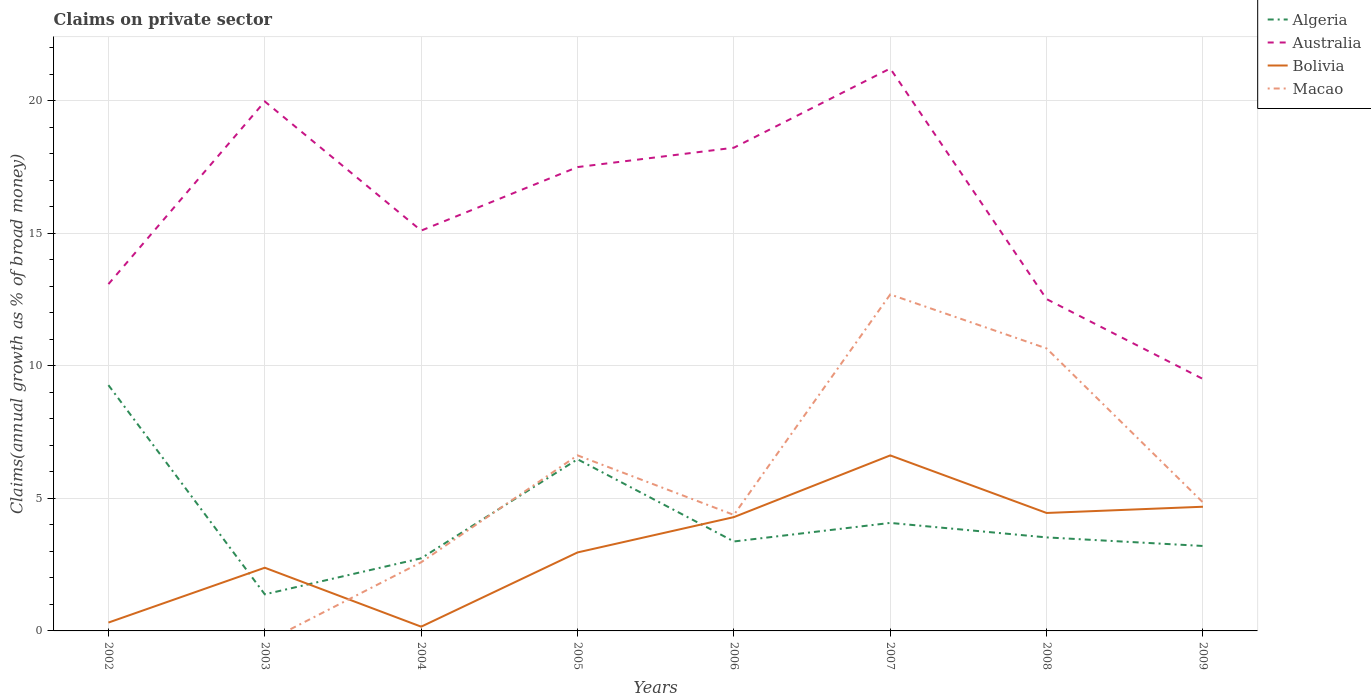How many different coloured lines are there?
Offer a terse response. 4. Is the number of lines equal to the number of legend labels?
Provide a short and direct response. No. Across all years, what is the maximum percentage of broad money claimed on private sector in Algeria?
Make the answer very short. 1.38. What is the total percentage of broad money claimed on private sector in Australia in the graph?
Make the answer very short. 8.73. What is the difference between the highest and the second highest percentage of broad money claimed on private sector in Macao?
Make the answer very short. 12.7. What is the difference between two consecutive major ticks on the Y-axis?
Offer a terse response. 5. Are the values on the major ticks of Y-axis written in scientific E-notation?
Ensure brevity in your answer.  No. Does the graph contain any zero values?
Your answer should be very brief. Yes. Where does the legend appear in the graph?
Your answer should be compact. Top right. How many legend labels are there?
Provide a short and direct response. 4. How are the legend labels stacked?
Make the answer very short. Vertical. What is the title of the graph?
Provide a short and direct response. Claims on private sector. What is the label or title of the X-axis?
Keep it short and to the point. Years. What is the label or title of the Y-axis?
Your answer should be very brief. Claims(annual growth as % of broad money). What is the Claims(annual growth as % of broad money) of Algeria in 2002?
Keep it short and to the point. 9.27. What is the Claims(annual growth as % of broad money) in Australia in 2002?
Your response must be concise. 13.09. What is the Claims(annual growth as % of broad money) in Bolivia in 2002?
Provide a succinct answer. 0.31. What is the Claims(annual growth as % of broad money) in Macao in 2002?
Provide a succinct answer. 0. What is the Claims(annual growth as % of broad money) of Algeria in 2003?
Offer a terse response. 1.38. What is the Claims(annual growth as % of broad money) of Australia in 2003?
Give a very brief answer. 19.98. What is the Claims(annual growth as % of broad money) of Bolivia in 2003?
Ensure brevity in your answer.  2.38. What is the Claims(annual growth as % of broad money) of Algeria in 2004?
Offer a terse response. 2.74. What is the Claims(annual growth as % of broad money) of Australia in 2004?
Provide a short and direct response. 15.11. What is the Claims(annual growth as % of broad money) of Bolivia in 2004?
Your answer should be compact. 0.16. What is the Claims(annual growth as % of broad money) in Macao in 2004?
Provide a succinct answer. 2.59. What is the Claims(annual growth as % of broad money) in Algeria in 2005?
Ensure brevity in your answer.  6.48. What is the Claims(annual growth as % of broad money) of Australia in 2005?
Provide a short and direct response. 17.5. What is the Claims(annual growth as % of broad money) of Bolivia in 2005?
Provide a succinct answer. 2.96. What is the Claims(annual growth as % of broad money) in Macao in 2005?
Give a very brief answer. 6.63. What is the Claims(annual growth as % of broad money) of Algeria in 2006?
Offer a terse response. 3.38. What is the Claims(annual growth as % of broad money) in Australia in 2006?
Your response must be concise. 18.23. What is the Claims(annual growth as % of broad money) in Bolivia in 2006?
Provide a short and direct response. 4.29. What is the Claims(annual growth as % of broad money) in Macao in 2006?
Your answer should be very brief. 4.38. What is the Claims(annual growth as % of broad money) of Algeria in 2007?
Offer a terse response. 4.08. What is the Claims(annual growth as % of broad money) of Australia in 2007?
Keep it short and to the point. 21.22. What is the Claims(annual growth as % of broad money) of Bolivia in 2007?
Provide a succinct answer. 6.62. What is the Claims(annual growth as % of broad money) in Macao in 2007?
Ensure brevity in your answer.  12.7. What is the Claims(annual growth as % of broad money) in Algeria in 2008?
Provide a short and direct response. 3.53. What is the Claims(annual growth as % of broad money) in Australia in 2008?
Keep it short and to the point. 12.52. What is the Claims(annual growth as % of broad money) of Bolivia in 2008?
Offer a very short reply. 4.45. What is the Claims(annual growth as % of broad money) of Macao in 2008?
Ensure brevity in your answer.  10.66. What is the Claims(annual growth as % of broad money) in Algeria in 2009?
Your answer should be very brief. 3.21. What is the Claims(annual growth as % of broad money) in Australia in 2009?
Give a very brief answer. 9.51. What is the Claims(annual growth as % of broad money) of Bolivia in 2009?
Your answer should be compact. 4.69. What is the Claims(annual growth as % of broad money) of Macao in 2009?
Offer a terse response. 4.85. Across all years, what is the maximum Claims(annual growth as % of broad money) of Algeria?
Give a very brief answer. 9.27. Across all years, what is the maximum Claims(annual growth as % of broad money) in Australia?
Offer a terse response. 21.22. Across all years, what is the maximum Claims(annual growth as % of broad money) of Bolivia?
Give a very brief answer. 6.62. Across all years, what is the maximum Claims(annual growth as % of broad money) in Macao?
Your answer should be very brief. 12.7. Across all years, what is the minimum Claims(annual growth as % of broad money) in Algeria?
Your answer should be very brief. 1.38. Across all years, what is the minimum Claims(annual growth as % of broad money) of Australia?
Keep it short and to the point. 9.51. Across all years, what is the minimum Claims(annual growth as % of broad money) in Bolivia?
Give a very brief answer. 0.16. What is the total Claims(annual growth as % of broad money) in Algeria in the graph?
Ensure brevity in your answer.  34.06. What is the total Claims(annual growth as % of broad money) in Australia in the graph?
Ensure brevity in your answer.  127.16. What is the total Claims(annual growth as % of broad money) in Bolivia in the graph?
Make the answer very short. 25.88. What is the total Claims(annual growth as % of broad money) in Macao in the graph?
Provide a succinct answer. 41.8. What is the difference between the Claims(annual growth as % of broad money) in Algeria in 2002 and that in 2003?
Give a very brief answer. 7.89. What is the difference between the Claims(annual growth as % of broad money) in Australia in 2002 and that in 2003?
Ensure brevity in your answer.  -6.89. What is the difference between the Claims(annual growth as % of broad money) of Bolivia in 2002 and that in 2003?
Your answer should be compact. -2.07. What is the difference between the Claims(annual growth as % of broad money) in Algeria in 2002 and that in 2004?
Give a very brief answer. 6.53. What is the difference between the Claims(annual growth as % of broad money) in Australia in 2002 and that in 2004?
Your answer should be compact. -2.02. What is the difference between the Claims(annual growth as % of broad money) in Bolivia in 2002 and that in 2004?
Provide a succinct answer. 0.15. What is the difference between the Claims(annual growth as % of broad money) of Algeria in 2002 and that in 2005?
Offer a very short reply. 2.8. What is the difference between the Claims(annual growth as % of broad money) of Australia in 2002 and that in 2005?
Your response must be concise. -4.42. What is the difference between the Claims(annual growth as % of broad money) in Bolivia in 2002 and that in 2005?
Ensure brevity in your answer.  -2.65. What is the difference between the Claims(annual growth as % of broad money) in Algeria in 2002 and that in 2006?
Ensure brevity in your answer.  5.9. What is the difference between the Claims(annual growth as % of broad money) in Australia in 2002 and that in 2006?
Your answer should be compact. -5.15. What is the difference between the Claims(annual growth as % of broad money) of Bolivia in 2002 and that in 2006?
Ensure brevity in your answer.  -3.98. What is the difference between the Claims(annual growth as % of broad money) in Algeria in 2002 and that in 2007?
Your answer should be very brief. 5.2. What is the difference between the Claims(annual growth as % of broad money) of Australia in 2002 and that in 2007?
Your answer should be very brief. -8.14. What is the difference between the Claims(annual growth as % of broad money) of Bolivia in 2002 and that in 2007?
Provide a short and direct response. -6.31. What is the difference between the Claims(annual growth as % of broad money) in Algeria in 2002 and that in 2008?
Keep it short and to the point. 5.75. What is the difference between the Claims(annual growth as % of broad money) of Australia in 2002 and that in 2008?
Your answer should be compact. 0.57. What is the difference between the Claims(annual growth as % of broad money) in Bolivia in 2002 and that in 2008?
Make the answer very short. -4.14. What is the difference between the Claims(annual growth as % of broad money) in Algeria in 2002 and that in 2009?
Provide a short and direct response. 6.07. What is the difference between the Claims(annual growth as % of broad money) of Australia in 2002 and that in 2009?
Ensure brevity in your answer.  3.58. What is the difference between the Claims(annual growth as % of broad money) of Bolivia in 2002 and that in 2009?
Offer a very short reply. -4.37. What is the difference between the Claims(annual growth as % of broad money) in Algeria in 2003 and that in 2004?
Your response must be concise. -1.36. What is the difference between the Claims(annual growth as % of broad money) in Australia in 2003 and that in 2004?
Your answer should be very brief. 4.87. What is the difference between the Claims(annual growth as % of broad money) in Bolivia in 2003 and that in 2004?
Make the answer very short. 2.22. What is the difference between the Claims(annual growth as % of broad money) of Algeria in 2003 and that in 2005?
Your response must be concise. -5.1. What is the difference between the Claims(annual growth as % of broad money) of Australia in 2003 and that in 2005?
Offer a very short reply. 2.48. What is the difference between the Claims(annual growth as % of broad money) in Bolivia in 2003 and that in 2005?
Your answer should be very brief. -0.58. What is the difference between the Claims(annual growth as % of broad money) in Algeria in 2003 and that in 2006?
Your answer should be compact. -1.99. What is the difference between the Claims(annual growth as % of broad money) of Australia in 2003 and that in 2006?
Make the answer very short. 1.75. What is the difference between the Claims(annual growth as % of broad money) in Bolivia in 2003 and that in 2006?
Offer a terse response. -1.91. What is the difference between the Claims(annual growth as % of broad money) of Algeria in 2003 and that in 2007?
Offer a very short reply. -2.69. What is the difference between the Claims(annual growth as % of broad money) in Australia in 2003 and that in 2007?
Ensure brevity in your answer.  -1.24. What is the difference between the Claims(annual growth as % of broad money) of Bolivia in 2003 and that in 2007?
Give a very brief answer. -4.24. What is the difference between the Claims(annual growth as % of broad money) of Algeria in 2003 and that in 2008?
Give a very brief answer. -2.15. What is the difference between the Claims(annual growth as % of broad money) in Australia in 2003 and that in 2008?
Offer a terse response. 7.46. What is the difference between the Claims(annual growth as % of broad money) of Bolivia in 2003 and that in 2008?
Make the answer very short. -2.07. What is the difference between the Claims(annual growth as % of broad money) of Algeria in 2003 and that in 2009?
Give a very brief answer. -1.82. What is the difference between the Claims(annual growth as % of broad money) of Australia in 2003 and that in 2009?
Keep it short and to the point. 10.47. What is the difference between the Claims(annual growth as % of broad money) in Bolivia in 2003 and that in 2009?
Give a very brief answer. -2.3. What is the difference between the Claims(annual growth as % of broad money) of Algeria in 2004 and that in 2005?
Your response must be concise. -3.74. What is the difference between the Claims(annual growth as % of broad money) in Australia in 2004 and that in 2005?
Keep it short and to the point. -2.4. What is the difference between the Claims(annual growth as % of broad money) of Bolivia in 2004 and that in 2005?
Offer a very short reply. -2.8. What is the difference between the Claims(annual growth as % of broad money) of Macao in 2004 and that in 2005?
Offer a very short reply. -4.03. What is the difference between the Claims(annual growth as % of broad money) of Algeria in 2004 and that in 2006?
Offer a very short reply. -0.64. What is the difference between the Claims(annual growth as % of broad money) in Australia in 2004 and that in 2006?
Give a very brief answer. -3.13. What is the difference between the Claims(annual growth as % of broad money) of Bolivia in 2004 and that in 2006?
Your answer should be compact. -4.13. What is the difference between the Claims(annual growth as % of broad money) of Macao in 2004 and that in 2006?
Provide a short and direct response. -1.79. What is the difference between the Claims(annual growth as % of broad money) of Algeria in 2004 and that in 2007?
Your answer should be very brief. -1.34. What is the difference between the Claims(annual growth as % of broad money) in Australia in 2004 and that in 2007?
Ensure brevity in your answer.  -6.12. What is the difference between the Claims(annual growth as % of broad money) in Bolivia in 2004 and that in 2007?
Provide a succinct answer. -6.46. What is the difference between the Claims(annual growth as % of broad money) in Macao in 2004 and that in 2007?
Your answer should be compact. -10.11. What is the difference between the Claims(annual growth as % of broad money) in Algeria in 2004 and that in 2008?
Keep it short and to the point. -0.79. What is the difference between the Claims(annual growth as % of broad money) of Australia in 2004 and that in 2008?
Your answer should be very brief. 2.58. What is the difference between the Claims(annual growth as % of broad money) in Bolivia in 2004 and that in 2008?
Provide a succinct answer. -4.29. What is the difference between the Claims(annual growth as % of broad money) of Macao in 2004 and that in 2008?
Your response must be concise. -8.07. What is the difference between the Claims(annual growth as % of broad money) in Algeria in 2004 and that in 2009?
Offer a very short reply. -0.47. What is the difference between the Claims(annual growth as % of broad money) in Australia in 2004 and that in 2009?
Offer a terse response. 5.6. What is the difference between the Claims(annual growth as % of broad money) of Bolivia in 2004 and that in 2009?
Your answer should be very brief. -4.53. What is the difference between the Claims(annual growth as % of broad money) in Macao in 2004 and that in 2009?
Ensure brevity in your answer.  -2.26. What is the difference between the Claims(annual growth as % of broad money) in Algeria in 2005 and that in 2006?
Offer a very short reply. 3.1. What is the difference between the Claims(annual growth as % of broad money) in Australia in 2005 and that in 2006?
Provide a succinct answer. -0.73. What is the difference between the Claims(annual growth as % of broad money) of Bolivia in 2005 and that in 2006?
Offer a terse response. -1.33. What is the difference between the Claims(annual growth as % of broad money) of Macao in 2005 and that in 2006?
Keep it short and to the point. 2.25. What is the difference between the Claims(annual growth as % of broad money) of Algeria in 2005 and that in 2007?
Your answer should be very brief. 2.4. What is the difference between the Claims(annual growth as % of broad money) of Australia in 2005 and that in 2007?
Offer a very short reply. -3.72. What is the difference between the Claims(annual growth as % of broad money) in Bolivia in 2005 and that in 2007?
Provide a short and direct response. -3.66. What is the difference between the Claims(annual growth as % of broad money) in Macao in 2005 and that in 2007?
Ensure brevity in your answer.  -6.07. What is the difference between the Claims(annual growth as % of broad money) of Algeria in 2005 and that in 2008?
Keep it short and to the point. 2.95. What is the difference between the Claims(annual growth as % of broad money) of Australia in 2005 and that in 2008?
Your answer should be compact. 4.98. What is the difference between the Claims(annual growth as % of broad money) in Bolivia in 2005 and that in 2008?
Make the answer very short. -1.49. What is the difference between the Claims(annual growth as % of broad money) of Macao in 2005 and that in 2008?
Keep it short and to the point. -4.03. What is the difference between the Claims(annual growth as % of broad money) in Algeria in 2005 and that in 2009?
Provide a short and direct response. 3.27. What is the difference between the Claims(annual growth as % of broad money) in Australia in 2005 and that in 2009?
Your answer should be very brief. 8. What is the difference between the Claims(annual growth as % of broad money) in Bolivia in 2005 and that in 2009?
Provide a succinct answer. -1.72. What is the difference between the Claims(annual growth as % of broad money) in Macao in 2005 and that in 2009?
Your answer should be very brief. 1.78. What is the difference between the Claims(annual growth as % of broad money) of Algeria in 2006 and that in 2007?
Your response must be concise. -0.7. What is the difference between the Claims(annual growth as % of broad money) of Australia in 2006 and that in 2007?
Your answer should be compact. -2.99. What is the difference between the Claims(annual growth as % of broad money) of Bolivia in 2006 and that in 2007?
Make the answer very short. -2.33. What is the difference between the Claims(annual growth as % of broad money) of Macao in 2006 and that in 2007?
Ensure brevity in your answer.  -8.32. What is the difference between the Claims(annual growth as % of broad money) of Algeria in 2006 and that in 2008?
Your answer should be very brief. -0.15. What is the difference between the Claims(annual growth as % of broad money) in Australia in 2006 and that in 2008?
Offer a very short reply. 5.71. What is the difference between the Claims(annual growth as % of broad money) in Bolivia in 2006 and that in 2008?
Make the answer very short. -0.16. What is the difference between the Claims(annual growth as % of broad money) in Macao in 2006 and that in 2008?
Offer a terse response. -6.28. What is the difference between the Claims(annual growth as % of broad money) of Algeria in 2006 and that in 2009?
Offer a terse response. 0.17. What is the difference between the Claims(annual growth as % of broad money) of Australia in 2006 and that in 2009?
Give a very brief answer. 8.73. What is the difference between the Claims(annual growth as % of broad money) in Bolivia in 2006 and that in 2009?
Your answer should be compact. -0.39. What is the difference between the Claims(annual growth as % of broad money) in Macao in 2006 and that in 2009?
Ensure brevity in your answer.  -0.47. What is the difference between the Claims(annual growth as % of broad money) of Algeria in 2007 and that in 2008?
Keep it short and to the point. 0.55. What is the difference between the Claims(annual growth as % of broad money) in Australia in 2007 and that in 2008?
Your answer should be very brief. 8.7. What is the difference between the Claims(annual growth as % of broad money) of Bolivia in 2007 and that in 2008?
Provide a succinct answer. 2.17. What is the difference between the Claims(annual growth as % of broad money) in Macao in 2007 and that in 2008?
Provide a short and direct response. 2.04. What is the difference between the Claims(annual growth as % of broad money) in Algeria in 2007 and that in 2009?
Your answer should be compact. 0.87. What is the difference between the Claims(annual growth as % of broad money) in Australia in 2007 and that in 2009?
Ensure brevity in your answer.  11.72. What is the difference between the Claims(annual growth as % of broad money) of Bolivia in 2007 and that in 2009?
Your answer should be compact. 1.94. What is the difference between the Claims(annual growth as % of broad money) in Macao in 2007 and that in 2009?
Provide a short and direct response. 7.85. What is the difference between the Claims(annual growth as % of broad money) of Algeria in 2008 and that in 2009?
Make the answer very short. 0.32. What is the difference between the Claims(annual growth as % of broad money) in Australia in 2008 and that in 2009?
Keep it short and to the point. 3.01. What is the difference between the Claims(annual growth as % of broad money) of Bolivia in 2008 and that in 2009?
Give a very brief answer. -0.24. What is the difference between the Claims(annual growth as % of broad money) of Macao in 2008 and that in 2009?
Make the answer very short. 5.81. What is the difference between the Claims(annual growth as % of broad money) of Algeria in 2002 and the Claims(annual growth as % of broad money) of Australia in 2003?
Provide a short and direct response. -10.71. What is the difference between the Claims(annual growth as % of broad money) of Algeria in 2002 and the Claims(annual growth as % of broad money) of Bolivia in 2003?
Offer a very short reply. 6.89. What is the difference between the Claims(annual growth as % of broad money) of Australia in 2002 and the Claims(annual growth as % of broad money) of Bolivia in 2003?
Your answer should be very brief. 10.7. What is the difference between the Claims(annual growth as % of broad money) in Algeria in 2002 and the Claims(annual growth as % of broad money) in Australia in 2004?
Offer a terse response. -5.83. What is the difference between the Claims(annual growth as % of broad money) of Algeria in 2002 and the Claims(annual growth as % of broad money) of Bolivia in 2004?
Ensure brevity in your answer.  9.11. What is the difference between the Claims(annual growth as % of broad money) in Algeria in 2002 and the Claims(annual growth as % of broad money) in Macao in 2004?
Ensure brevity in your answer.  6.68. What is the difference between the Claims(annual growth as % of broad money) of Australia in 2002 and the Claims(annual growth as % of broad money) of Bolivia in 2004?
Offer a very short reply. 12.93. What is the difference between the Claims(annual growth as % of broad money) in Australia in 2002 and the Claims(annual growth as % of broad money) in Macao in 2004?
Your answer should be very brief. 10.5. What is the difference between the Claims(annual growth as % of broad money) of Bolivia in 2002 and the Claims(annual growth as % of broad money) of Macao in 2004?
Provide a short and direct response. -2.28. What is the difference between the Claims(annual growth as % of broad money) of Algeria in 2002 and the Claims(annual growth as % of broad money) of Australia in 2005?
Your answer should be compact. -8.23. What is the difference between the Claims(annual growth as % of broad money) of Algeria in 2002 and the Claims(annual growth as % of broad money) of Bolivia in 2005?
Offer a very short reply. 6.31. What is the difference between the Claims(annual growth as % of broad money) of Algeria in 2002 and the Claims(annual growth as % of broad money) of Macao in 2005?
Provide a succinct answer. 2.65. What is the difference between the Claims(annual growth as % of broad money) of Australia in 2002 and the Claims(annual growth as % of broad money) of Bolivia in 2005?
Your answer should be compact. 10.13. What is the difference between the Claims(annual growth as % of broad money) of Australia in 2002 and the Claims(annual growth as % of broad money) of Macao in 2005?
Provide a short and direct response. 6.46. What is the difference between the Claims(annual growth as % of broad money) of Bolivia in 2002 and the Claims(annual growth as % of broad money) of Macao in 2005?
Ensure brevity in your answer.  -6.31. What is the difference between the Claims(annual growth as % of broad money) in Algeria in 2002 and the Claims(annual growth as % of broad money) in Australia in 2006?
Provide a succinct answer. -8.96. What is the difference between the Claims(annual growth as % of broad money) in Algeria in 2002 and the Claims(annual growth as % of broad money) in Bolivia in 2006?
Your response must be concise. 4.98. What is the difference between the Claims(annual growth as % of broad money) of Algeria in 2002 and the Claims(annual growth as % of broad money) of Macao in 2006?
Your answer should be compact. 4.9. What is the difference between the Claims(annual growth as % of broad money) of Australia in 2002 and the Claims(annual growth as % of broad money) of Bolivia in 2006?
Provide a short and direct response. 8.79. What is the difference between the Claims(annual growth as % of broad money) of Australia in 2002 and the Claims(annual growth as % of broad money) of Macao in 2006?
Your answer should be very brief. 8.71. What is the difference between the Claims(annual growth as % of broad money) of Bolivia in 2002 and the Claims(annual growth as % of broad money) of Macao in 2006?
Your answer should be compact. -4.06. What is the difference between the Claims(annual growth as % of broad money) of Algeria in 2002 and the Claims(annual growth as % of broad money) of Australia in 2007?
Your answer should be compact. -11.95. What is the difference between the Claims(annual growth as % of broad money) of Algeria in 2002 and the Claims(annual growth as % of broad money) of Bolivia in 2007?
Provide a succinct answer. 2.65. What is the difference between the Claims(annual growth as % of broad money) in Algeria in 2002 and the Claims(annual growth as % of broad money) in Macao in 2007?
Your answer should be very brief. -3.42. What is the difference between the Claims(annual growth as % of broad money) in Australia in 2002 and the Claims(annual growth as % of broad money) in Bolivia in 2007?
Your answer should be compact. 6.46. What is the difference between the Claims(annual growth as % of broad money) of Australia in 2002 and the Claims(annual growth as % of broad money) of Macao in 2007?
Offer a very short reply. 0.39. What is the difference between the Claims(annual growth as % of broad money) in Bolivia in 2002 and the Claims(annual growth as % of broad money) in Macao in 2007?
Offer a terse response. -12.38. What is the difference between the Claims(annual growth as % of broad money) of Algeria in 2002 and the Claims(annual growth as % of broad money) of Australia in 2008?
Offer a terse response. -3.25. What is the difference between the Claims(annual growth as % of broad money) of Algeria in 2002 and the Claims(annual growth as % of broad money) of Bolivia in 2008?
Provide a succinct answer. 4.82. What is the difference between the Claims(annual growth as % of broad money) of Algeria in 2002 and the Claims(annual growth as % of broad money) of Macao in 2008?
Offer a terse response. -1.39. What is the difference between the Claims(annual growth as % of broad money) of Australia in 2002 and the Claims(annual growth as % of broad money) of Bolivia in 2008?
Your response must be concise. 8.64. What is the difference between the Claims(annual growth as % of broad money) in Australia in 2002 and the Claims(annual growth as % of broad money) in Macao in 2008?
Your answer should be very brief. 2.43. What is the difference between the Claims(annual growth as % of broad money) of Bolivia in 2002 and the Claims(annual growth as % of broad money) of Macao in 2008?
Give a very brief answer. -10.34. What is the difference between the Claims(annual growth as % of broad money) of Algeria in 2002 and the Claims(annual growth as % of broad money) of Australia in 2009?
Give a very brief answer. -0.23. What is the difference between the Claims(annual growth as % of broad money) in Algeria in 2002 and the Claims(annual growth as % of broad money) in Bolivia in 2009?
Make the answer very short. 4.59. What is the difference between the Claims(annual growth as % of broad money) in Algeria in 2002 and the Claims(annual growth as % of broad money) in Macao in 2009?
Your response must be concise. 4.43. What is the difference between the Claims(annual growth as % of broad money) of Australia in 2002 and the Claims(annual growth as % of broad money) of Bolivia in 2009?
Offer a terse response. 8.4. What is the difference between the Claims(annual growth as % of broad money) of Australia in 2002 and the Claims(annual growth as % of broad money) of Macao in 2009?
Provide a succinct answer. 8.24. What is the difference between the Claims(annual growth as % of broad money) in Bolivia in 2002 and the Claims(annual growth as % of broad money) in Macao in 2009?
Provide a short and direct response. -4.53. What is the difference between the Claims(annual growth as % of broad money) in Algeria in 2003 and the Claims(annual growth as % of broad money) in Australia in 2004?
Keep it short and to the point. -13.72. What is the difference between the Claims(annual growth as % of broad money) in Algeria in 2003 and the Claims(annual growth as % of broad money) in Bolivia in 2004?
Make the answer very short. 1.22. What is the difference between the Claims(annual growth as % of broad money) in Algeria in 2003 and the Claims(annual growth as % of broad money) in Macao in 2004?
Ensure brevity in your answer.  -1.21. What is the difference between the Claims(annual growth as % of broad money) in Australia in 2003 and the Claims(annual growth as % of broad money) in Bolivia in 2004?
Your answer should be compact. 19.82. What is the difference between the Claims(annual growth as % of broad money) of Australia in 2003 and the Claims(annual growth as % of broad money) of Macao in 2004?
Offer a very short reply. 17.39. What is the difference between the Claims(annual growth as % of broad money) of Bolivia in 2003 and the Claims(annual growth as % of broad money) of Macao in 2004?
Provide a short and direct response. -0.21. What is the difference between the Claims(annual growth as % of broad money) in Algeria in 2003 and the Claims(annual growth as % of broad money) in Australia in 2005?
Your answer should be very brief. -16.12. What is the difference between the Claims(annual growth as % of broad money) of Algeria in 2003 and the Claims(annual growth as % of broad money) of Bolivia in 2005?
Keep it short and to the point. -1.58. What is the difference between the Claims(annual growth as % of broad money) in Algeria in 2003 and the Claims(annual growth as % of broad money) in Macao in 2005?
Your response must be concise. -5.24. What is the difference between the Claims(annual growth as % of broad money) of Australia in 2003 and the Claims(annual growth as % of broad money) of Bolivia in 2005?
Your answer should be compact. 17.02. What is the difference between the Claims(annual growth as % of broad money) of Australia in 2003 and the Claims(annual growth as % of broad money) of Macao in 2005?
Provide a short and direct response. 13.35. What is the difference between the Claims(annual growth as % of broad money) of Bolivia in 2003 and the Claims(annual growth as % of broad money) of Macao in 2005?
Provide a short and direct response. -4.24. What is the difference between the Claims(annual growth as % of broad money) in Algeria in 2003 and the Claims(annual growth as % of broad money) in Australia in 2006?
Your response must be concise. -16.85. What is the difference between the Claims(annual growth as % of broad money) in Algeria in 2003 and the Claims(annual growth as % of broad money) in Bolivia in 2006?
Your answer should be very brief. -2.91. What is the difference between the Claims(annual growth as % of broad money) of Algeria in 2003 and the Claims(annual growth as % of broad money) of Macao in 2006?
Keep it short and to the point. -3. What is the difference between the Claims(annual growth as % of broad money) of Australia in 2003 and the Claims(annual growth as % of broad money) of Bolivia in 2006?
Your response must be concise. 15.69. What is the difference between the Claims(annual growth as % of broad money) in Australia in 2003 and the Claims(annual growth as % of broad money) in Macao in 2006?
Your answer should be compact. 15.6. What is the difference between the Claims(annual growth as % of broad money) of Bolivia in 2003 and the Claims(annual growth as % of broad money) of Macao in 2006?
Offer a terse response. -1.99. What is the difference between the Claims(annual growth as % of broad money) of Algeria in 2003 and the Claims(annual growth as % of broad money) of Australia in 2007?
Ensure brevity in your answer.  -19.84. What is the difference between the Claims(annual growth as % of broad money) in Algeria in 2003 and the Claims(annual growth as % of broad money) in Bolivia in 2007?
Provide a succinct answer. -5.24. What is the difference between the Claims(annual growth as % of broad money) in Algeria in 2003 and the Claims(annual growth as % of broad money) in Macao in 2007?
Your answer should be very brief. -11.32. What is the difference between the Claims(annual growth as % of broad money) of Australia in 2003 and the Claims(annual growth as % of broad money) of Bolivia in 2007?
Offer a very short reply. 13.36. What is the difference between the Claims(annual growth as % of broad money) of Australia in 2003 and the Claims(annual growth as % of broad money) of Macao in 2007?
Give a very brief answer. 7.28. What is the difference between the Claims(annual growth as % of broad money) in Bolivia in 2003 and the Claims(annual growth as % of broad money) in Macao in 2007?
Offer a very short reply. -10.31. What is the difference between the Claims(annual growth as % of broad money) of Algeria in 2003 and the Claims(annual growth as % of broad money) of Australia in 2008?
Offer a very short reply. -11.14. What is the difference between the Claims(annual growth as % of broad money) of Algeria in 2003 and the Claims(annual growth as % of broad money) of Bolivia in 2008?
Offer a terse response. -3.07. What is the difference between the Claims(annual growth as % of broad money) of Algeria in 2003 and the Claims(annual growth as % of broad money) of Macao in 2008?
Offer a very short reply. -9.28. What is the difference between the Claims(annual growth as % of broad money) of Australia in 2003 and the Claims(annual growth as % of broad money) of Bolivia in 2008?
Make the answer very short. 15.53. What is the difference between the Claims(annual growth as % of broad money) of Australia in 2003 and the Claims(annual growth as % of broad money) of Macao in 2008?
Your response must be concise. 9.32. What is the difference between the Claims(annual growth as % of broad money) of Bolivia in 2003 and the Claims(annual growth as % of broad money) of Macao in 2008?
Your response must be concise. -8.28. What is the difference between the Claims(annual growth as % of broad money) in Algeria in 2003 and the Claims(annual growth as % of broad money) in Australia in 2009?
Your response must be concise. -8.13. What is the difference between the Claims(annual growth as % of broad money) in Algeria in 2003 and the Claims(annual growth as % of broad money) in Bolivia in 2009?
Make the answer very short. -3.31. What is the difference between the Claims(annual growth as % of broad money) of Algeria in 2003 and the Claims(annual growth as % of broad money) of Macao in 2009?
Ensure brevity in your answer.  -3.47. What is the difference between the Claims(annual growth as % of broad money) in Australia in 2003 and the Claims(annual growth as % of broad money) in Bolivia in 2009?
Give a very brief answer. 15.29. What is the difference between the Claims(annual growth as % of broad money) in Australia in 2003 and the Claims(annual growth as % of broad money) in Macao in 2009?
Make the answer very short. 15.13. What is the difference between the Claims(annual growth as % of broad money) of Bolivia in 2003 and the Claims(annual growth as % of broad money) of Macao in 2009?
Provide a succinct answer. -2.46. What is the difference between the Claims(annual growth as % of broad money) of Algeria in 2004 and the Claims(annual growth as % of broad money) of Australia in 2005?
Your response must be concise. -14.76. What is the difference between the Claims(annual growth as % of broad money) in Algeria in 2004 and the Claims(annual growth as % of broad money) in Bolivia in 2005?
Give a very brief answer. -0.22. What is the difference between the Claims(annual growth as % of broad money) in Algeria in 2004 and the Claims(annual growth as % of broad money) in Macao in 2005?
Provide a short and direct response. -3.89. What is the difference between the Claims(annual growth as % of broad money) of Australia in 2004 and the Claims(annual growth as % of broad money) of Bolivia in 2005?
Provide a short and direct response. 12.14. What is the difference between the Claims(annual growth as % of broad money) of Australia in 2004 and the Claims(annual growth as % of broad money) of Macao in 2005?
Offer a terse response. 8.48. What is the difference between the Claims(annual growth as % of broad money) in Bolivia in 2004 and the Claims(annual growth as % of broad money) in Macao in 2005?
Offer a terse response. -6.46. What is the difference between the Claims(annual growth as % of broad money) of Algeria in 2004 and the Claims(annual growth as % of broad money) of Australia in 2006?
Make the answer very short. -15.49. What is the difference between the Claims(annual growth as % of broad money) in Algeria in 2004 and the Claims(annual growth as % of broad money) in Bolivia in 2006?
Give a very brief answer. -1.55. What is the difference between the Claims(annual growth as % of broad money) in Algeria in 2004 and the Claims(annual growth as % of broad money) in Macao in 2006?
Offer a very short reply. -1.64. What is the difference between the Claims(annual growth as % of broad money) in Australia in 2004 and the Claims(annual growth as % of broad money) in Bolivia in 2006?
Give a very brief answer. 10.81. What is the difference between the Claims(annual growth as % of broad money) in Australia in 2004 and the Claims(annual growth as % of broad money) in Macao in 2006?
Your answer should be very brief. 10.73. What is the difference between the Claims(annual growth as % of broad money) in Bolivia in 2004 and the Claims(annual growth as % of broad money) in Macao in 2006?
Your response must be concise. -4.22. What is the difference between the Claims(annual growth as % of broad money) of Algeria in 2004 and the Claims(annual growth as % of broad money) of Australia in 2007?
Offer a terse response. -18.48. What is the difference between the Claims(annual growth as % of broad money) in Algeria in 2004 and the Claims(annual growth as % of broad money) in Bolivia in 2007?
Give a very brief answer. -3.88. What is the difference between the Claims(annual growth as % of broad money) of Algeria in 2004 and the Claims(annual growth as % of broad money) of Macao in 2007?
Give a very brief answer. -9.96. What is the difference between the Claims(annual growth as % of broad money) of Australia in 2004 and the Claims(annual growth as % of broad money) of Bolivia in 2007?
Your answer should be very brief. 8.48. What is the difference between the Claims(annual growth as % of broad money) of Australia in 2004 and the Claims(annual growth as % of broad money) of Macao in 2007?
Give a very brief answer. 2.41. What is the difference between the Claims(annual growth as % of broad money) of Bolivia in 2004 and the Claims(annual growth as % of broad money) of Macao in 2007?
Your answer should be compact. -12.54. What is the difference between the Claims(annual growth as % of broad money) of Algeria in 2004 and the Claims(annual growth as % of broad money) of Australia in 2008?
Give a very brief answer. -9.78. What is the difference between the Claims(annual growth as % of broad money) in Algeria in 2004 and the Claims(annual growth as % of broad money) in Bolivia in 2008?
Offer a terse response. -1.71. What is the difference between the Claims(annual growth as % of broad money) of Algeria in 2004 and the Claims(annual growth as % of broad money) of Macao in 2008?
Offer a very short reply. -7.92. What is the difference between the Claims(annual growth as % of broad money) in Australia in 2004 and the Claims(annual growth as % of broad money) in Bolivia in 2008?
Your answer should be compact. 10.65. What is the difference between the Claims(annual growth as % of broad money) in Australia in 2004 and the Claims(annual growth as % of broad money) in Macao in 2008?
Make the answer very short. 4.45. What is the difference between the Claims(annual growth as % of broad money) in Bolivia in 2004 and the Claims(annual growth as % of broad money) in Macao in 2008?
Your response must be concise. -10.5. What is the difference between the Claims(annual growth as % of broad money) of Algeria in 2004 and the Claims(annual growth as % of broad money) of Australia in 2009?
Your response must be concise. -6.77. What is the difference between the Claims(annual growth as % of broad money) of Algeria in 2004 and the Claims(annual growth as % of broad money) of Bolivia in 2009?
Your response must be concise. -1.95. What is the difference between the Claims(annual growth as % of broad money) of Algeria in 2004 and the Claims(annual growth as % of broad money) of Macao in 2009?
Offer a very short reply. -2.11. What is the difference between the Claims(annual growth as % of broad money) of Australia in 2004 and the Claims(annual growth as % of broad money) of Bolivia in 2009?
Ensure brevity in your answer.  10.42. What is the difference between the Claims(annual growth as % of broad money) of Australia in 2004 and the Claims(annual growth as % of broad money) of Macao in 2009?
Your response must be concise. 10.26. What is the difference between the Claims(annual growth as % of broad money) in Bolivia in 2004 and the Claims(annual growth as % of broad money) in Macao in 2009?
Keep it short and to the point. -4.69. What is the difference between the Claims(annual growth as % of broad money) of Algeria in 2005 and the Claims(annual growth as % of broad money) of Australia in 2006?
Ensure brevity in your answer.  -11.76. What is the difference between the Claims(annual growth as % of broad money) in Algeria in 2005 and the Claims(annual growth as % of broad money) in Bolivia in 2006?
Offer a very short reply. 2.18. What is the difference between the Claims(annual growth as % of broad money) in Algeria in 2005 and the Claims(annual growth as % of broad money) in Macao in 2006?
Your answer should be very brief. 2.1. What is the difference between the Claims(annual growth as % of broad money) of Australia in 2005 and the Claims(annual growth as % of broad money) of Bolivia in 2006?
Your answer should be very brief. 13.21. What is the difference between the Claims(annual growth as % of broad money) of Australia in 2005 and the Claims(annual growth as % of broad money) of Macao in 2006?
Give a very brief answer. 13.13. What is the difference between the Claims(annual growth as % of broad money) of Bolivia in 2005 and the Claims(annual growth as % of broad money) of Macao in 2006?
Your answer should be very brief. -1.42. What is the difference between the Claims(annual growth as % of broad money) of Algeria in 2005 and the Claims(annual growth as % of broad money) of Australia in 2007?
Give a very brief answer. -14.75. What is the difference between the Claims(annual growth as % of broad money) of Algeria in 2005 and the Claims(annual growth as % of broad money) of Bolivia in 2007?
Provide a short and direct response. -0.15. What is the difference between the Claims(annual growth as % of broad money) of Algeria in 2005 and the Claims(annual growth as % of broad money) of Macao in 2007?
Provide a short and direct response. -6.22. What is the difference between the Claims(annual growth as % of broad money) of Australia in 2005 and the Claims(annual growth as % of broad money) of Bolivia in 2007?
Your answer should be compact. 10.88. What is the difference between the Claims(annual growth as % of broad money) of Australia in 2005 and the Claims(annual growth as % of broad money) of Macao in 2007?
Your answer should be compact. 4.81. What is the difference between the Claims(annual growth as % of broad money) in Bolivia in 2005 and the Claims(annual growth as % of broad money) in Macao in 2007?
Offer a very short reply. -9.73. What is the difference between the Claims(annual growth as % of broad money) of Algeria in 2005 and the Claims(annual growth as % of broad money) of Australia in 2008?
Your answer should be very brief. -6.04. What is the difference between the Claims(annual growth as % of broad money) of Algeria in 2005 and the Claims(annual growth as % of broad money) of Bolivia in 2008?
Make the answer very short. 2.03. What is the difference between the Claims(annual growth as % of broad money) in Algeria in 2005 and the Claims(annual growth as % of broad money) in Macao in 2008?
Offer a very short reply. -4.18. What is the difference between the Claims(annual growth as % of broad money) in Australia in 2005 and the Claims(annual growth as % of broad money) in Bolivia in 2008?
Provide a short and direct response. 13.05. What is the difference between the Claims(annual growth as % of broad money) in Australia in 2005 and the Claims(annual growth as % of broad money) in Macao in 2008?
Make the answer very short. 6.84. What is the difference between the Claims(annual growth as % of broad money) of Bolivia in 2005 and the Claims(annual growth as % of broad money) of Macao in 2008?
Offer a terse response. -7.7. What is the difference between the Claims(annual growth as % of broad money) in Algeria in 2005 and the Claims(annual growth as % of broad money) in Australia in 2009?
Provide a succinct answer. -3.03. What is the difference between the Claims(annual growth as % of broad money) of Algeria in 2005 and the Claims(annual growth as % of broad money) of Bolivia in 2009?
Your answer should be very brief. 1.79. What is the difference between the Claims(annual growth as % of broad money) in Algeria in 2005 and the Claims(annual growth as % of broad money) in Macao in 2009?
Ensure brevity in your answer.  1.63. What is the difference between the Claims(annual growth as % of broad money) of Australia in 2005 and the Claims(annual growth as % of broad money) of Bolivia in 2009?
Your answer should be very brief. 12.82. What is the difference between the Claims(annual growth as % of broad money) of Australia in 2005 and the Claims(annual growth as % of broad money) of Macao in 2009?
Make the answer very short. 12.65. What is the difference between the Claims(annual growth as % of broad money) in Bolivia in 2005 and the Claims(annual growth as % of broad money) in Macao in 2009?
Offer a terse response. -1.89. What is the difference between the Claims(annual growth as % of broad money) of Algeria in 2006 and the Claims(annual growth as % of broad money) of Australia in 2007?
Give a very brief answer. -17.85. What is the difference between the Claims(annual growth as % of broad money) in Algeria in 2006 and the Claims(annual growth as % of broad money) in Bolivia in 2007?
Keep it short and to the point. -3.25. What is the difference between the Claims(annual growth as % of broad money) in Algeria in 2006 and the Claims(annual growth as % of broad money) in Macao in 2007?
Give a very brief answer. -9.32. What is the difference between the Claims(annual growth as % of broad money) of Australia in 2006 and the Claims(annual growth as % of broad money) of Bolivia in 2007?
Your answer should be very brief. 11.61. What is the difference between the Claims(annual growth as % of broad money) of Australia in 2006 and the Claims(annual growth as % of broad money) of Macao in 2007?
Provide a succinct answer. 5.54. What is the difference between the Claims(annual growth as % of broad money) of Bolivia in 2006 and the Claims(annual growth as % of broad money) of Macao in 2007?
Provide a short and direct response. -8.4. What is the difference between the Claims(annual growth as % of broad money) of Algeria in 2006 and the Claims(annual growth as % of broad money) of Australia in 2008?
Provide a succinct answer. -9.15. What is the difference between the Claims(annual growth as % of broad money) in Algeria in 2006 and the Claims(annual growth as % of broad money) in Bolivia in 2008?
Make the answer very short. -1.08. What is the difference between the Claims(annual growth as % of broad money) in Algeria in 2006 and the Claims(annual growth as % of broad money) in Macao in 2008?
Your response must be concise. -7.28. What is the difference between the Claims(annual growth as % of broad money) in Australia in 2006 and the Claims(annual growth as % of broad money) in Bolivia in 2008?
Your answer should be very brief. 13.78. What is the difference between the Claims(annual growth as % of broad money) in Australia in 2006 and the Claims(annual growth as % of broad money) in Macao in 2008?
Make the answer very short. 7.57. What is the difference between the Claims(annual growth as % of broad money) in Bolivia in 2006 and the Claims(annual growth as % of broad money) in Macao in 2008?
Offer a very short reply. -6.37. What is the difference between the Claims(annual growth as % of broad money) in Algeria in 2006 and the Claims(annual growth as % of broad money) in Australia in 2009?
Your answer should be very brief. -6.13. What is the difference between the Claims(annual growth as % of broad money) in Algeria in 2006 and the Claims(annual growth as % of broad money) in Bolivia in 2009?
Give a very brief answer. -1.31. What is the difference between the Claims(annual growth as % of broad money) of Algeria in 2006 and the Claims(annual growth as % of broad money) of Macao in 2009?
Give a very brief answer. -1.47. What is the difference between the Claims(annual growth as % of broad money) of Australia in 2006 and the Claims(annual growth as % of broad money) of Bolivia in 2009?
Your response must be concise. 13.55. What is the difference between the Claims(annual growth as % of broad money) in Australia in 2006 and the Claims(annual growth as % of broad money) in Macao in 2009?
Offer a terse response. 13.39. What is the difference between the Claims(annual growth as % of broad money) in Bolivia in 2006 and the Claims(annual growth as % of broad money) in Macao in 2009?
Offer a very short reply. -0.55. What is the difference between the Claims(annual growth as % of broad money) in Algeria in 2007 and the Claims(annual growth as % of broad money) in Australia in 2008?
Give a very brief answer. -8.45. What is the difference between the Claims(annual growth as % of broad money) of Algeria in 2007 and the Claims(annual growth as % of broad money) of Bolivia in 2008?
Provide a succinct answer. -0.38. What is the difference between the Claims(annual growth as % of broad money) in Algeria in 2007 and the Claims(annual growth as % of broad money) in Macao in 2008?
Your answer should be compact. -6.58. What is the difference between the Claims(annual growth as % of broad money) of Australia in 2007 and the Claims(annual growth as % of broad money) of Bolivia in 2008?
Your response must be concise. 16.77. What is the difference between the Claims(annual growth as % of broad money) in Australia in 2007 and the Claims(annual growth as % of broad money) in Macao in 2008?
Your answer should be very brief. 10.56. What is the difference between the Claims(annual growth as % of broad money) of Bolivia in 2007 and the Claims(annual growth as % of broad money) of Macao in 2008?
Offer a terse response. -4.04. What is the difference between the Claims(annual growth as % of broad money) in Algeria in 2007 and the Claims(annual growth as % of broad money) in Australia in 2009?
Make the answer very short. -5.43. What is the difference between the Claims(annual growth as % of broad money) of Algeria in 2007 and the Claims(annual growth as % of broad money) of Bolivia in 2009?
Your answer should be compact. -0.61. What is the difference between the Claims(annual growth as % of broad money) in Algeria in 2007 and the Claims(annual growth as % of broad money) in Macao in 2009?
Provide a short and direct response. -0.77. What is the difference between the Claims(annual growth as % of broad money) of Australia in 2007 and the Claims(annual growth as % of broad money) of Bolivia in 2009?
Keep it short and to the point. 16.54. What is the difference between the Claims(annual growth as % of broad money) of Australia in 2007 and the Claims(annual growth as % of broad money) of Macao in 2009?
Offer a very short reply. 16.37. What is the difference between the Claims(annual growth as % of broad money) of Bolivia in 2007 and the Claims(annual growth as % of broad money) of Macao in 2009?
Give a very brief answer. 1.77. What is the difference between the Claims(annual growth as % of broad money) in Algeria in 2008 and the Claims(annual growth as % of broad money) in Australia in 2009?
Ensure brevity in your answer.  -5.98. What is the difference between the Claims(annual growth as % of broad money) in Algeria in 2008 and the Claims(annual growth as % of broad money) in Bolivia in 2009?
Your response must be concise. -1.16. What is the difference between the Claims(annual growth as % of broad money) of Algeria in 2008 and the Claims(annual growth as % of broad money) of Macao in 2009?
Offer a very short reply. -1.32. What is the difference between the Claims(annual growth as % of broad money) in Australia in 2008 and the Claims(annual growth as % of broad money) in Bolivia in 2009?
Your response must be concise. 7.83. What is the difference between the Claims(annual growth as % of broad money) of Australia in 2008 and the Claims(annual growth as % of broad money) of Macao in 2009?
Provide a succinct answer. 7.67. What is the difference between the Claims(annual growth as % of broad money) in Bolivia in 2008 and the Claims(annual growth as % of broad money) in Macao in 2009?
Ensure brevity in your answer.  -0.4. What is the average Claims(annual growth as % of broad money) of Algeria per year?
Offer a very short reply. 4.26. What is the average Claims(annual growth as % of broad money) in Australia per year?
Provide a succinct answer. 15.9. What is the average Claims(annual growth as % of broad money) in Bolivia per year?
Offer a very short reply. 3.23. What is the average Claims(annual growth as % of broad money) in Macao per year?
Provide a succinct answer. 5.22. In the year 2002, what is the difference between the Claims(annual growth as % of broad money) in Algeria and Claims(annual growth as % of broad money) in Australia?
Your answer should be compact. -3.81. In the year 2002, what is the difference between the Claims(annual growth as % of broad money) in Algeria and Claims(annual growth as % of broad money) in Bolivia?
Provide a succinct answer. 8.96. In the year 2002, what is the difference between the Claims(annual growth as % of broad money) of Australia and Claims(annual growth as % of broad money) of Bolivia?
Your answer should be compact. 12.77. In the year 2003, what is the difference between the Claims(annual growth as % of broad money) in Algeria and Claims(annual growth as % of broad money) in Australia?
Make the answer very short. -18.6. In the year 2003, what is the difference between the Claims(annual growth as % of broad money) in Algeria and Claims(annual growth as % of broad money) in Bolivia?
Provide a succinct answer. -1. In the year 2003, what is the difference between the Claims(annual growth as % of broad money) in Australia and Claims(annual growth as % of broad money) in Bolivia?
Your response must be concise. 17.6. In the year 2004, what is the difference between the Claims(annual growth as % of broad money) in Algeria and Claims(annual growth as % of broad money) in Australia?
Provide a short and direct response. -12.37. In the year 2004, what is the difference between the Claims(annual growth as % of broad money) in Algeria and Claims(annual growth as % of broad money) in Bolivia?
Your answer should be very brief. 2.58. In the year 2004, what is the difference between the Claims(annual growth as % of broad money) in Algeria and Claims(annual growth as % of broad money) in Macao?
Give a very brief answer. 0.15. In the year 2004, what is the difference between the Claims(annual growth as % of broad money) of Australia and Claims(annual growth as % of broad money) of Bolivia?
Offer a very short reply. 14.95. In the year 2004, what is the difference between the Claims(annual growth as % of broad money) in Australia and Claims(annual growth as % of broad money) in Macao?
Ensure brevity in your answer.  12.52. In the year 2004, what is the difference between the Claims(annual growth as % of broad money) in Bolivia and Claims(annual growth as % of broad money) in Macao?
Give a very brief answer. -2.43. In the year 2005, what is the difference between the Claims(annual growth as % of broad money) of Algeria and Claims(annual growth as % of broad money) of Australia?
Provide a succinct answer. -11.03. In the year 2005, what is the difference between the Claims(annual growth as % of broad money) in Algeria and Claims(annual growth as % of broad money) in Bolivia?
Your answer should be compact. 3.52. In the year 2005, what is the difference between the Claims(annual growth as % of broad money) of Algeria and Claims(annual growth as % of broad money) of Macao?
Give a very brief answer. -0.15. In the year 2005, what is the difference between the Claims(annual growth as % of broad money) in Australia and Claims(annual growth as % of broad money) in Bolivia?
Give a very brief answer. 14.54. In the year 2005, what is the difference between the Claims(annual growth as % of broad money) in Australia and Claims(annual growth as % of broad money) in Macao?
Provide a short and direct response. 10.88. In the year 2005, what is the difference between the Claims(annual growth as % of broad money) in Bolivia and Claims(annual growth as % of broad money) in Macao?
Offer a very short reply. -3.66. In the year 2006, what is the difference between the Claims(annual growth as % of broad money) in Algeria and Claims(annual growth as % of broad money) in Australia?
Your response must be concise. -14.86. In the year 2006, what is the difference between the Claims(annual growth as % of broad money) in Algeria and Claims(annual growth as % of broad money) in Bolivia?
Offer a terse response. -0.92. In the year 2006, what is the difference between the Claims(annual growth as % of broad money) of Algeria and Claims(annual growth as % of broad money) of Macao?
Give a very brief answer. -1. In the year 2006, what is the difference between the Claims(annual growth as % of broad money) in Australia and Claims(annual growth as % of broad money) in Bolivia?
Give a very brief answer. 13.94. In the year 2006, what is the difference between the Claims(annual growth as % of broad money) of Australia and Claims(annual growth as % of broad money) of Macao?
Ensure brevity in your answer.  13.86. In the year 2006, what is the difference between the Claims(annual growth as % of broad money) of Bolivia and Claims(annual growth as % of broad money) of Macao?
Your answer should be very brief. -0.08. In the year 2007, what is the difference between the Claims(annual growth as % of broad money) of Algeria and Claims(annual growth as % of broad money) of Australia?
Provide a succinct answer. -17.15. In the year 2007, what is the difference between the Claims(annual growth as % of broad money) in Algeria and Claims(annual growth as % of broad money) in Bolivia?
Keep it short and to the point. -2.55. In the year 2007, what is the difference between the Claims(annual growth as % of broad money) in Algeria and Claims(annual growth as % of broad money) in Macao?
Provide a short and direct response. -8.62. In the year 2007, what is the difference between the Claims(annual growth as % of broad money) in Australia and Claims(annual growth as % of broad money) in Bolivia?
Give a very brief answer. 14.6. In the year 2007, what is the difference between the Claims(annual growth as % of broad money) in Australia and Claims(annual growth as % of broad money) in Macao?
Keep it short and to the point. 8.53. In the year 2007, what is the difference between the Claims(annual growth as % of broad money) of Bolivia and Claims(annual growth as % of broad money) of Macao?
Your answer should be very brief. -6.07. In the year 2008, what is the difference between the Claims(annual growth as % of broad money) of Algeria and Claims(annual growth as % of broad money) of Australia?
Give a very brief answer. -8.99. In the year 2008, what is the difference between the Claims(annual growth as % of broad money) of Algeria and Claims(annual growth as % of broad money) of Bolivia?
Ensure brevity in your answer.  -0.92. In the year 2008, what is the difference between the Claims(annual growth as % of broad money) in Algeria and Claims(annual growth as % of broad money) in Macao?
Provide a short and direct response. -7.13. In the year 2008, what is the difference between the Claims(annual growth as % of broad money) of Australia and Claims(annual growth as % of broad money) of Bolivia?
Make the answer very short. 8.07. In the year 2008, what is the difference between the Claims(annual growth as % of broad money) in Australia and Claims(annual growth as % of broad money) in Macao?
Provide a short and direct response. 1.86. In the year 2008, what is the difference between the Claims(annual growth as % of broad money) in Bolivia and Claims(annual growth as % of broad money) in Macao?
Your answer should be compact. -6.21. In the year 2009, what is the difference between the Claims(annual growth as % of broad money) of Algeria and Claims(annual growth as % of broad money) of Australia?
Keep it short and to the point. -6.3. In the year 2009, what is the difference between the Claims(annual growth as % of broad money) of Algeria and Claims(annual growth as % of broad money) of Bolivia?
Provide a succinct answer. -1.48. In the year 2009, what is the difference between the Claims(annual growth as % of broad money) of Algeria and Claims(annual growth as % of broad money) of Macao?
Provide a short and direct response. -1.64. In the year 2009, what is the difference between the Claims(annual growth as % of broad money) in Australia and Claims(annual growth as % of broad money) in Bolivia?
Your answer should be very brief. 4.82. In the year 2009, what is the difference between the Claims(annual growth as % of broad money) in Australia and Claims(annual growth as % of broad money) in Macao?
Offer a terse response. 4.66. In the year 2009, what is the difference between the Claims(annual growth as % of broad money) in Bolivia and Claims(annual growth as % of broad money) in Macao?
Offer a very short reply. -0.16. What is the ratio of the Claims(annual growth as % of broad money) of Algeria in 2002 to that in 2003?
Your response must be concise. 6.72. What is the ratio of the Claims(annual growth as % of broad money) of Australia in 2002 to that in 2003?
Offer a terse response. 0.66. What is the ratio of the Claims(annual growth as % of broad money) in Bolivia in 2002 to that in 2003?
Keep it short and to the point. 0.13. What is the ratio of the Claims(annual growth as % of broad money) in Algeria in 2002 to that in 2004?
Provide a succinct answer. 3.38. What is the ratio of the Claims(annual growth as % of broad money) in Australia in 2002 to that in 2004?
Give a very brief answer. 0.87. What is the ratio of the Claims(annual growth as % of broad money) of Bolivia in 2002 to that in 2004?
Ensure brevity in your answer.  1.96. What is the ratio of the Claims(annual growth as % of broad money) of Algeria in 2002 to that in 2005?
Make the answer very short. 1.43. What is the ratio of the Claims(annual growth as % of broad money) of Australia in 2002 to that in 2005?
Offer a terse response. 0.75. What is the ratio of the Claims(annual growth as % of broad money) of Bolivia in 2002 to that in 2005?
Offer a very short reply. 0.11. What is the ratio of the Claims(annual growth as % of broad money) in Algeria in 2002 to that in 2006?
Offer a terse response. 2.75. What is the ratio of the Claims(annual growth as % of broad money) of Australia in 2002 to that in 2006?
Offer a terse response. 0.72. What is the ratio of the Claims(annual growth as % of broad money) of Bolivia in 2002 to that in 2006?
Provide a succinct answer. 0.07. What is the ratio of the Claims(annual growth as % of broad money) in Algeria in 2002 to that in 2007?
Provide a succinct answer. 2.28. What is the ratio of the Claims(annual growth as % of broad money) in Australia in 2002 to that in 2007?
Ensure brevity in your answer.  0.62. What is the ratio of the Claims(annual growth as % of broad money) in Bolivia in 2002 to that in 2007?
Offer a terse response. 0.05. What is the ratio of the Claims(annual growth as % of broad money) in Algeria in 2002 to that in 2008?
Give a very brief answer. 2.63. What is the ratio of the Claims(annual growth as % of broad money) of Australia in 2002 to that in 2008?
Offer a very short reply. 1.05. What is the ratio of the Claims(annual growth as % of broad money) in Bolivia in 2002 to that in 2008?
Offer a very short reply. 0.07. What is the ratio of the Claims(annual growth as % of broad money) of Algeria in 2002 to that in 2009?
Provide a succinct answer. 2.89. What is the ratio of the Claims(annual growth as % of broad money) in Australia in 2002 to that in 2009?
Ensure brevity in your answer.  1.38. What is the ratio of the Claims(annual growth as % of broad money) of Bolivia in 2002 to that in 2009?
Provide a succinct answer. 0.07. What is the ratio of the Claims(annual growth as % of broad money) of Algeria in 2003 to that in 2004?
Ensure brevity in your answer.  0.5. What is the ratio of the Claims(annual growth as % of broad money) in Australia in 2003 to that in 2004?
Your answer should be very brief. 1.32. What is the ratio of the Claims(annual growth as % of broad money) of Bolivia in 2003 to that in 2004?
Keep it short and to the point. 14.86. What is the ratio of the Claims(annual growth as % of broad money) of Algeria in 2003 to that in 2005?
Offer a very short reply. 0.21. What is the ratio of the Claims(annual growth as % of broad money) of Australia in 2003 to that in 2005?
Your response must be concise. 1.14. What is the ratio of the Claims(annual growth as % of broad money) in Bolivia in 2003 to that in 2005?
Offer a terse response. 0.81. What is the ratio of the Claims(annual growth as % of broad money) of Algeria in 2003 to that in 2006?
Your answer should be very brief. 0.41. What is the ratio of the Claims(annual growth as % of broad money) of Australia in 2003 to that in 2006?
Your answer should be very brief. 1.1. What is the ratio of the Claims(annual growth as % of broad money) in Bolivia in 2003 to that in 2006?
Your answer should be compact. 0.56. What is the ratio of the Claims(annual growth as % of broad money) in Algeria in 2003 to that in 2007?
Your answer should be very brief. 0.34. What is the ratio of the Claims(annual growth as % of broad money) of Australia in 2003 to that in 2007?
Your answer should be compact. 0.94. What is the ratio of the Claims(annual growth as % of broad money) in Bolivia in 2003 to that in 2007?
Give a very brief answer. 0.36. What is the ratio of the Claims(annual growth as % of broad money) of Algeria in 2003 to that in 2008?
Offer a very short reply. 0.39. What is the ratio of the Claims(annual growth as % of broad money) in Australia in 2003 to that in 2008?
Keep it short and to the point. 1.6. What is the ratio of the Claims(annual growth as % of broad money) of Bolivia in 2003 to that in 2008?
Your answer should be compact. 0.54. What is the ratio of the Claims(annual growth as % of broad money) of Algeria in 2003 to that in 2009?
Ensure brevity in your answer.  0.43. What is the ratio of the Claims(annual growth as % of broad money) of Australia in 2003 to that in 2009?
Provide a short and direct response. 2.1. What is the ratio of the Claims(annual growth as % of broad money) of Bolivia in 2003 to that in 2009?
Offer a very short reply. 0.51. What is the ratio of the Claims(annual growth as % of broad money) of Algeria in 2004 to that in 2005?
Your response must be concise. 0.42. What is the ratio of the Claims(annual growth as % of broad money) of Australia in 2004 to that in 2005?
Your answer should be very brief. 0.86. What is the ratio of the Claims(annual growth as % of broad money) of Bolivia in 2004 to that in 2005?
Your answer should be compact. 0.05. What is the ratio of the Claims(annual growth as % of broad money) in Macao in 2004 to that in 2005?
Your answer should be compact. 0.39. What is the ratio of the Claims(annual growth as % of broad money) of Algeria in 2004 to that in 2006?
Provide a short and direct response. 0.81. What is the ratio of the Claims(annual growth as % of broad money) in Australia in 2004 to that in 2006?
Your answer should be compact. 0.83. What is the ratio of the Claims(annual growth as % of broad money) of Bolivia in 2004 to that in 2006?
Provide a succinct answer. 0.04. What is the ratio of the Claims(annual growth as % of broad money) of Macao in 2004 to that in 2006?
Ensure brevity in your answer.  0.59. What is the ratio of the Claims(annual growth as % of broad money) of Algeria in 2004 to that in 2007?
Give a very brief answer. 0.67. What is the ratio of the Claims(annual growth as % of broad money) of Australia in 2004 to that in 2007?
Your answer should be very brief. 0.71. What is the ratio of the Claims(annual growth as % of broad money) of Bolivia in 2004 to that in 2007?
Provide a succinct answer. 0.02. What is the ratio of the Claims(annual growth as % of broad money) in Macao in 2004 to that in 2007?
Offer a terse response. 0.2. What is the ratio of the Claims(annual growth as % of broad money) of Algeria in 2004 to that in 2008?
Provide a short and direct response. 0.78. What is the ratio of the Claims(annual growth as % of broad money) of Australia in 2004 to that in 2008?
Keep it short and to the point. 1.21. What is the ratio of the Claims(annual growth as % of broad money) of Bolivia in 2004 to that in 2008?
Make the answer very short. 0.04. What is the ratio of the Claims(annual growth as % of broad money) of Macao in 2004 to that in 2008?
Provide a succinct answer. 0.24. What is the ratio of the Claims(annual growth as % of broad money) in Algeria in 2004 to that in 2009?
Offer a terse response. 0.85. What is the ratio of the Claims(annual growth as % of broad money) of Australia in 2004 to that in 2009?
Keep it short and to the point. 1.59. What is the ratio of the Claims(annual growth as % of broad money) in Bolivia in 2004 to that in 2009?
Provide a succinct answer. 0.03. What is the ratio of the Claims(annual growth as % of broad money) in Macao in 2004 to that in 2009?
Give a very brief answer. 0.53. What is the ratio of the Claims(annual growth as % of broad money) in Algeria in 2005 to that in 2006?
Offer a terse response. 1.92. What is the ratio of the Claims(annual growth as % of broad money) of Australia in 2005 to that in 2006?
Offer a terse response. 0.96. What is the ratio of the Claims(annual growth as % of broad money) of Bolivia in 2005 to that in 2006?
Provide a short and direct response. 0.69. What is the ratio of the Claims(annual growth as % of broad money) in Macao in 2005 to that in 2006?
Ensure brevity in your answer.  1.51. What is the ratio of the Claims(annual growth as % of broad money) of Algeria in 2005 to that in 2007?
Give a very brief answer. 1.59. What is the ratio of the Claims(annual growth as % of broad money) in Australia in 2005 to that in 2007?
Your answer should be compact. 0.82. What is the ratio of the Claims(annual growth as % of broad money) in Bolivia in 2005 to that in 2007?
Make the answer very short. 0.45. What is the ratio of the Claims(annual growth as % of broad money) of Macao in 2005 to that in 2007?
Offer a terse response. 0.52. What is the ratio of the Claims(annual growth as % of broad money) of Algeria in 2005 to that in 2008?
Offer a very short reply. 1.84. What is the ratio of the Claims(annual growth as % of broad money) in Australia in 2005 to that in 2008?
Ensure brevity in your answer.  1.4. What is the ratio of the Claims(annual growth as % of broad money) of Bolivia in 2005 to that in 2008?
Make the answer very short. 0.67. What is the ratio of the Claims(annual growth as % of broad money) in Macao in 2005 to that in 2008?
Ensure brevity in your answer.  0.62. What is the ratio of the Claims(annual growth as % of broad money) of Algeria in 2005 to that in 2009?
Your answer should be compact. 2.02. What is the ratio of the Claims(annual growth as % of broad money) in Australia in 2005 to that in 2009?
Provide a short and direct response. 1.84. What is the ratio of the Claims(annual growth as % of broad money) of Bolivia in 2005 to that in 2009?
Your answer should be very brief. 0.63. What is the ratio of the Claims(annual growth as % of broad money) of Macao in 2005 to that in 2009?
Offer a terse response. 1.37. What is the ratio of the Claims(annual growth as % of broad money) in Algeria in 2006 to that in 2007?
Ensure brevity in your answer.  0.83. What is the ratio of the Claims(annual growth as % of broad money) in Australia in 2006 to that in 2007?
Offer a terse response. 0.86. What is the ratio of the Claims(annual growth as % of broad money) of Bolivia in 2006 to that in 2007?
Provide a succinct answer. 0.65. What is the ratio of the Claims(annual growth as % of broad money) of Macao in 2006 to that in 2007?
Give a very brief answer. 0.34. What is the ratio of the Claims(annual growth as % of broad money) in Algeria in 2006 to that in 2008?
Offer a very short reply. 0.96. What is the ratio of the Claims(annual growth as % of broad money) in Australia in 2006 to that in 2008?
Your response must be concise. 1.46. What is the ratio of the Claims(annual growth as % of broad money) in Bolivia in 2006 to that in 2008?
Offer a terse response. 0.96. What is the ratio of the Claims(annual growth as % of broad money) in Macao in 2006 to that in 2008?
Provide a succinct answer. 0.41. What is the ratio of the Claims(annual growth as % of broad money) of Algeria in 2006 to that in 2009?
Provide a succinct answer. 1.05. What is the ratio of the Claims(annual growth as % of broad money) of Australia in 2006 to that in 2009?
Keep it short and to the point. 1.92. What is the ratio of the Claims(annual growth as % of broad money) in Bolivia in 2006 to that in 2009?
Keep it short and to the point. 0.92. What is the ratio of the Claims(annual growth as % of broad money) of Macao in 2006 to that in 2009?
Your answer should be compact. 0.9. What is the ratio of the Claims(annual growth as % of broad money) in Algeria in 2007 to that in 2008?
Provide a short and direct response. 1.15. What is the ratio of the Claims(annual growth as % of broad money) in Australia in 2007 to that in 2008?
Provide a short and direct response. 1.7. What is the ratio of the Claims(annual growth as % of broad money) of Bolivia in 2007 to that in 2008?
Your response must be concise. 1.49. What is the ratio of the Claims(annual growth as % of broad money) in Macao in 2007 to that in 2008?
Give a very brief answer. 1.19. What is the ratio of the Claims(annual growth as % of broad money) in Algeria in 2007 to that in 2009?
Your answer should be very brief. 1.27. What is the ratio of the Claims(annual growth as % of broad money) in Australia in 2007 to that in 2009?
Keep it short and to the point. 2.23. What is the ratio of the Claims(annual growth as % of broad money) in Bolivia in 2007 to that in 2009?
Your answer should be very brief. 1.41. What is the ratio of the Claims(annual growth as % of broad money) of Macao in 2007 to that in 2009?
Give a very brief answer. 2.62. What is the ratio of the Claims(annual growth as % of broad money) of Algeria in 2008 to that in 2009?
Your answer should be very brief. 1.1. What is the ratio of the Claims(annual growth as % of broad money) of Australia in 2008 to that in 2009?
Give a very brief answer. 1.32. What is the ratio of the Claims(annual growth as % of broad money) in Bolivia in 2008 to that in 2009?
Give a very brief answer. 0.95. What is the ratio of the Claims(annual growth as % of broad money) in Macao in 2008 to that in 2009?
Ensure brevity in your answer.  2.2. What is the difference between the highest and the second highest Claims(annual growth as % of broad money) of Algeria?
Provide a short and direct response. 2.8. What is the difference between the highest and the second highest Claims(annual growth as % of broad money) in Australia?
Make the answer very short. 1.24. What is the difference between the highest and the second highest Claims(annual growth as % of broad money) of Bolivia?
Your response must be concise. 1.94. What is the difference between the highest and the second highest Claims(annual growth as % of broad money) in Macao?
Provide a short and direct response. 2.04. What is the difference between the highest and the lowest Claims(annual growth as % of broad money) in Algeria?
Make the answer very short. 7.89. What is the difference between the highest and the lowest Claims(annual growth as % of broad money) of Australia?
Offer a terse response. 11.72. What is the difference between the highest and the lowest Claims(annual growth as % of broad money) of Bolivia?
Keep it short and to the point. 6.46. What is the difference between the highest and the lowest Claims(annual growth as % of broad money) of Macao?
Give a very brief answer. 12.7. 